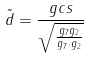<formula> <loc_0><loc_0><loc_500><loc_500>\tilde { d } = \frac { g c s } { \sqrt { \frac { g _ { 7 } g _ { 2 } } { g _ { 7 } \cdot g _ { 2 } } } }</formula> 